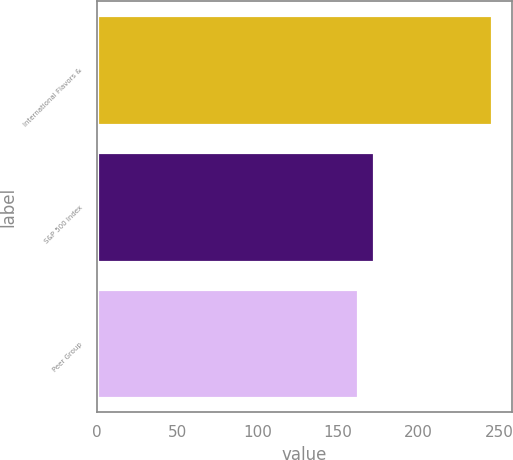Convert chart. <chart><loc_0><loc_0><loc_500><loc_500><bar_chart><fcel>International Flavors &<fcel>S&P 500 Index<fcel>Peer Group<nl><fcel>245.35<fcel>172.37<fcel>162.14<nl></chart> 